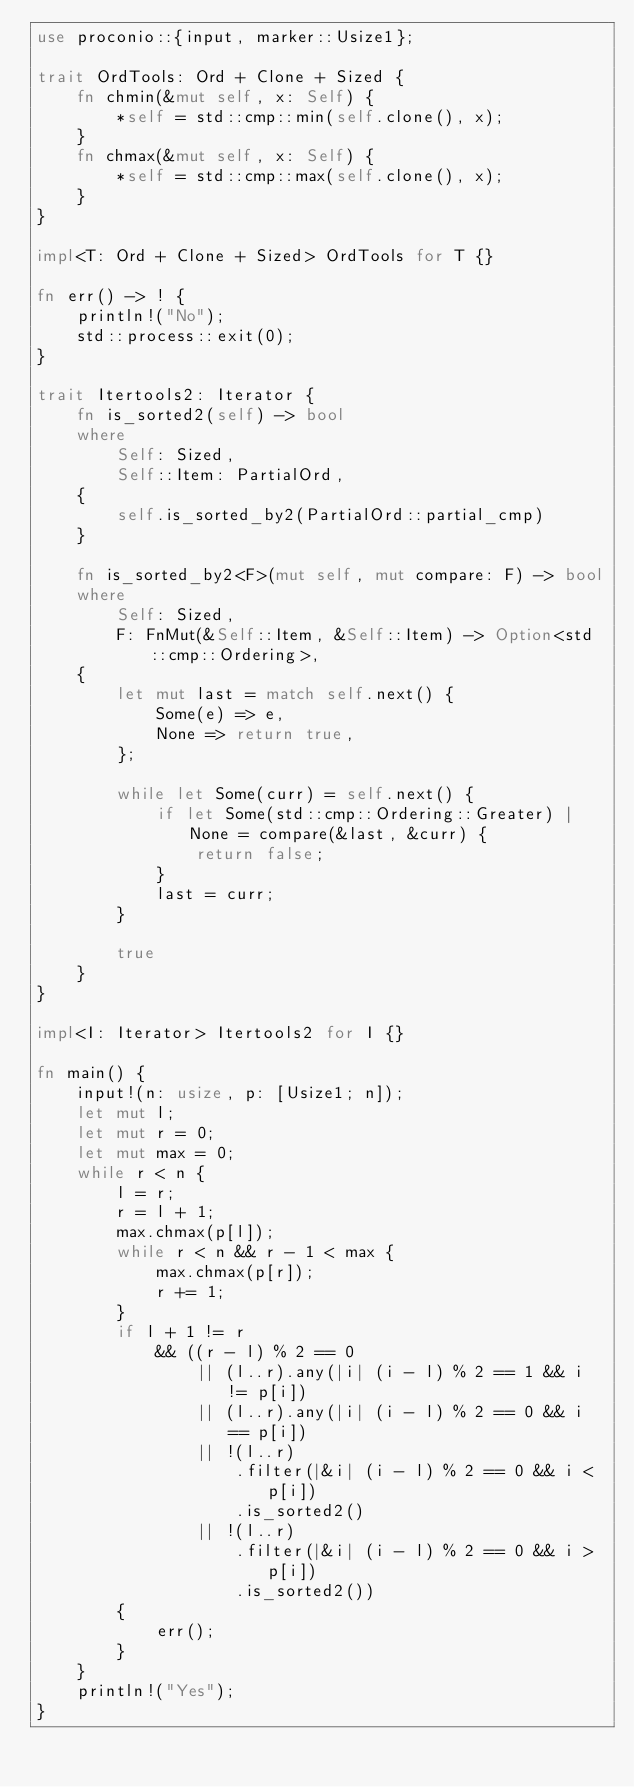Convert code to text. <code><loc_0><loc_0><loc_500><loc_500><_Rust_>use proconio::{input, marker::Usize1};

trait OrdTools: Ord + Clone + Sized {
    fn chmin(&mut self, x: Self) {
        *self = std::cmp::min(self.clone(), x);
    }
    fn chmax(&mut self, x: Self) {
        *self = std::cmp::max(self.clone(), x);
    }
}

impl<T: Ord + Clone + Sized> OrdTools for T {}

fn err() -> ! {
    println!("No");
    std::process::exit(0);
}

trait Itertools2: Iterator {
    fn is_sorted2(self) -> bool
    where
        Self: Sized,
        Self::Item: PartialOrd,
    {
        self.is_sorted_by2(PartialOrd::partial_cmp)
    }

    fn is_sorted_by2<F>(mut self, mut compare: F) -> bool
    where
        Self: Sized,
        F: FnMut(&Self::Item, &Self::Item) -> Option<std::cmp::Ordering>,
    {
        let mut last = match self.next() {
            Some(e) => e,
            None => return true,
        };

        while let Some(curr) = self.next() {
            if let Some(std::cmp::Ordering::Greater) | None = compare(&last, &curr) {
                return false;
            }
            last = curr;
        }

        true
    }
}

impl<I: Iterator> Itertools2 for I {}

fn main() {
    input!(n: usize, p: [Usize1; n]);
    let mut l;
    let mut r = 0;
    let mut max = 0;
    while r < n {
        l = r;
        r = l + 1;
        max.chmax(p[l]);
        while r < n && r - 1 < max {
            max.chmax(p[r]);
            r += 1;
        }
        if l + 1 != r
            && ((r - l) % 2 == 0
                || (l..r).any(|i| (i - l) % 2 == 1 && i != p[i])
                || (l..r).any(|i| (i - l) % 2 == 0 && i == p[i])
                || !(l..r)
                    .filter(|&i| (i - l) % 2 == 0 && i < p[i])
                    .is_sorted2()
                || !(l..r)
                    .filter(|&i| (i - l) % 2 == 0 && i > p[i])
                    .is_sorted2())
        {
            err();
        }
    }
    println!("Yes");
}
</code> 